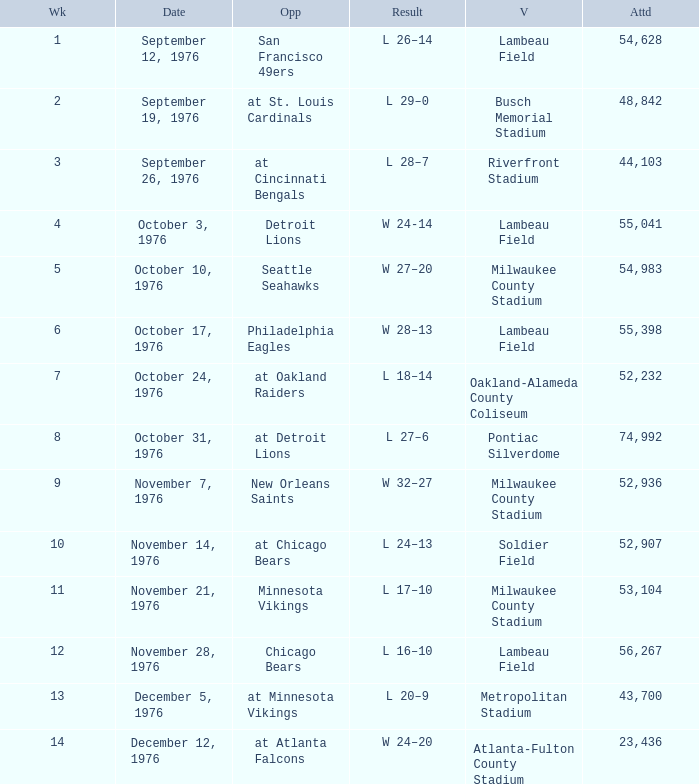Would you mind parsing the complete table? {'header': ['Wk', 'Date', 'Opp', 'Result', 'V', 'Attd'], 'rows': [['1', 'September 12, 1976', 'San Francisco 49ers', 'L 26–14', 'Lambeau Field', '54,628'], ['2', 'September 19, 1976', 'at St. Louis Cardinals', 'L 29–0', 'Busch Memorial Stadium', '48,842'], ['3', 'September 26, 1976', 'at Cincinnati Bengals', 'L 28–7', 'Riverfront Stadium', '44,103'], ['4', 'October 3, 1976', 'Detroit Lions', 'W 24-14', 'Lambeau Field', '55,041'], ['5', 'October 10, 1976', 'Seattle Seahawks', 'W 27–20', 'Milwaukee County Stadium', '54,983'], ['6', 'October 17, 1976', 'Philadelphia Eagles', 'W 28–13', 'Lambeau Field', '55,398'], ['7', 'October 24, 1976', 'at Oakland Raiders', 'L 18–14', 'Oakland-Alameda County Coliseum', '52,232'], ['8', 'October 31, 1976', 'at Detroit Lions', 'L 27–6', 'Pontiac Silverdome', '74,992'], ['9', 'November 7, 1976', 'New Orleans Saints', 'W 32–27', 'Milwaukee County Stadium', '52,936'], ['10', 'November 14, 1976', 'at Chicago Bears', 'L 24–13', 'Soldier Field', '52,907'], ['11', 'November 21, 1976', 'Minnesota Vikings', 'L 17–10', 'Milwaukee County Stadium', '53,104'], ['12', 'November 28, 1976', 'Chicago Bears', 'L 16–10', 'Lambeau Field', '56,267'], ['13', 'December 5, 1976', 'at Minnesota Vikings', 'L 20–9', 'Metropolitan Stadium', '43,700'], ['14', 'December 12, 1976', 'at Atlanta Falcons', 'W 24–20', 'Atlanta-Fulton County Stadium', '23,436']]} What is the average attendance for the game on September 26, 1976? 44103.0. 